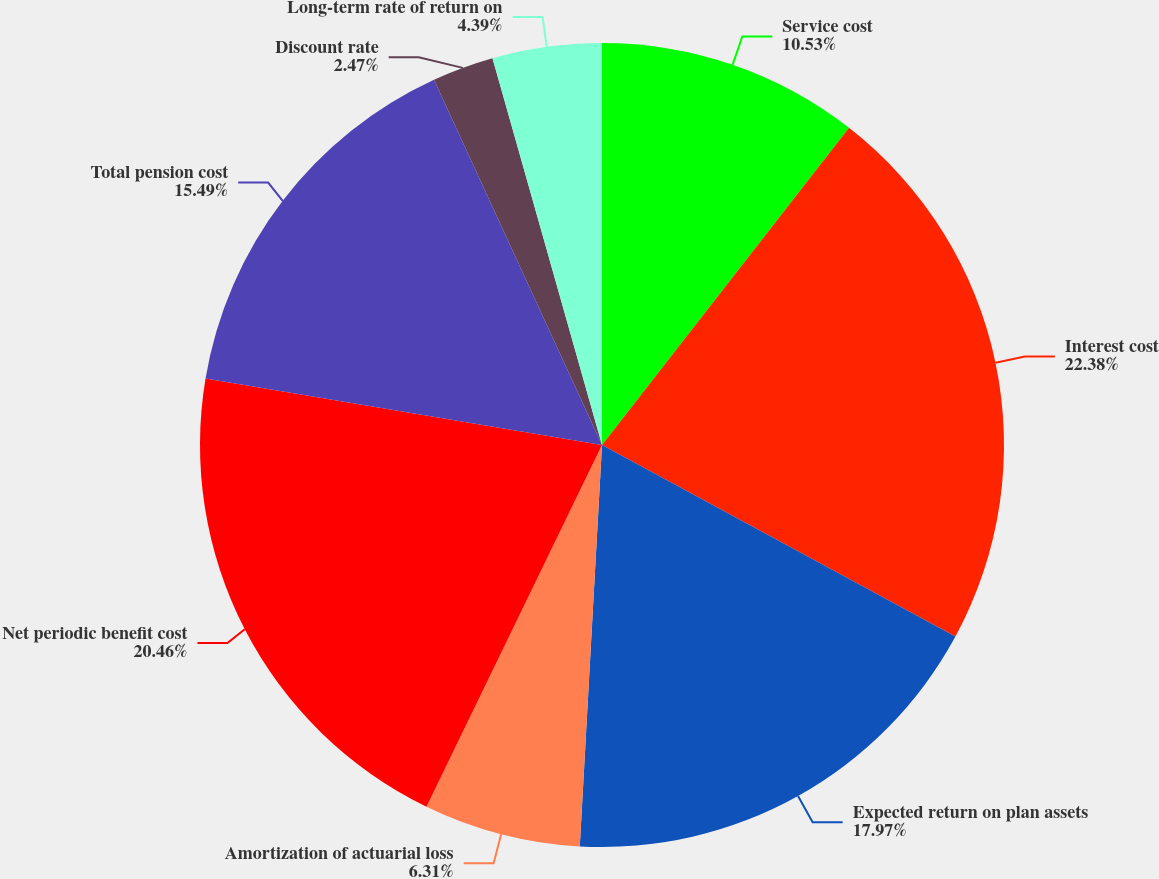Convert chart to OTSL. <chart><loc_0><loc_0><loc_500><loc_500><pie_chart><fcel>Service cost<fcel>Interest cost<fcel>Expected return on plan assets<fcel>Amortization of actuarial loss<fcel>Net periodic benefit cost<fcel>Total pension cost<fcel>Discount rate<fcel>Long-term rate of return on<nl><fcel>10.53%<fcel>22.37%<fcel>17.97%<fcel>6.31%<fcel>20.45%<fcel>15.49%<fcel>2.47%<fcel>4.39%<nl></chart> 